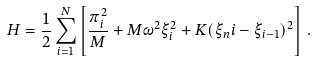Convert formula to latex. <formula><loc_0><loc_0><loc_500><loc_500>H = \frac { 1 } { 2 } \sum _ { i = 1 } ^ { N } \left [ \frac { \pi _ { i } ^ { 2 } } { M } + M \omega ^ { 2 } \xi _ { i } ^ { 2 } + K ( \xi _ { n } i - \xi _ { i - 1 } ) ^ { 2 } \right ] \, .</formula> 